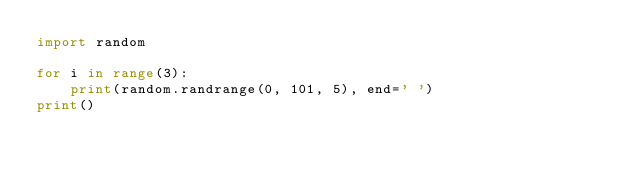Convert code to text. <code><loc_0><loc_0><loc_500><loc_500><_Python_>import random

for i in range(3):
    print(random.randrange(0, 101, 5), end=' ')
print()
</code> 